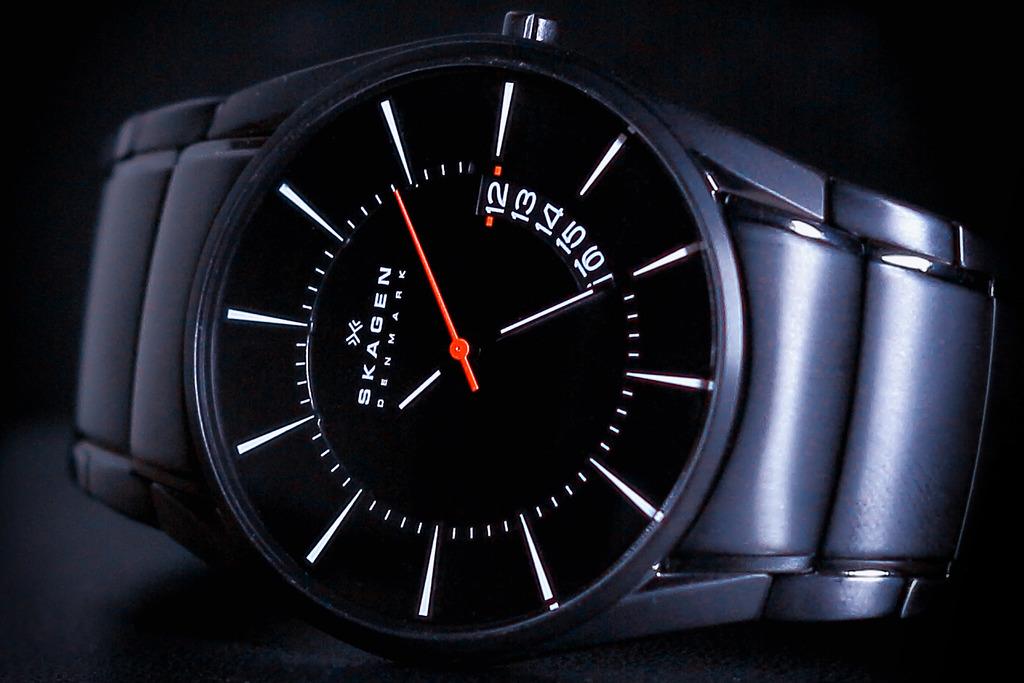What country is this watch made in?
Ensure brevity in your answer.  Denmark. What is the brand name of this watch?
Your answer should be very brief. Skagen. 